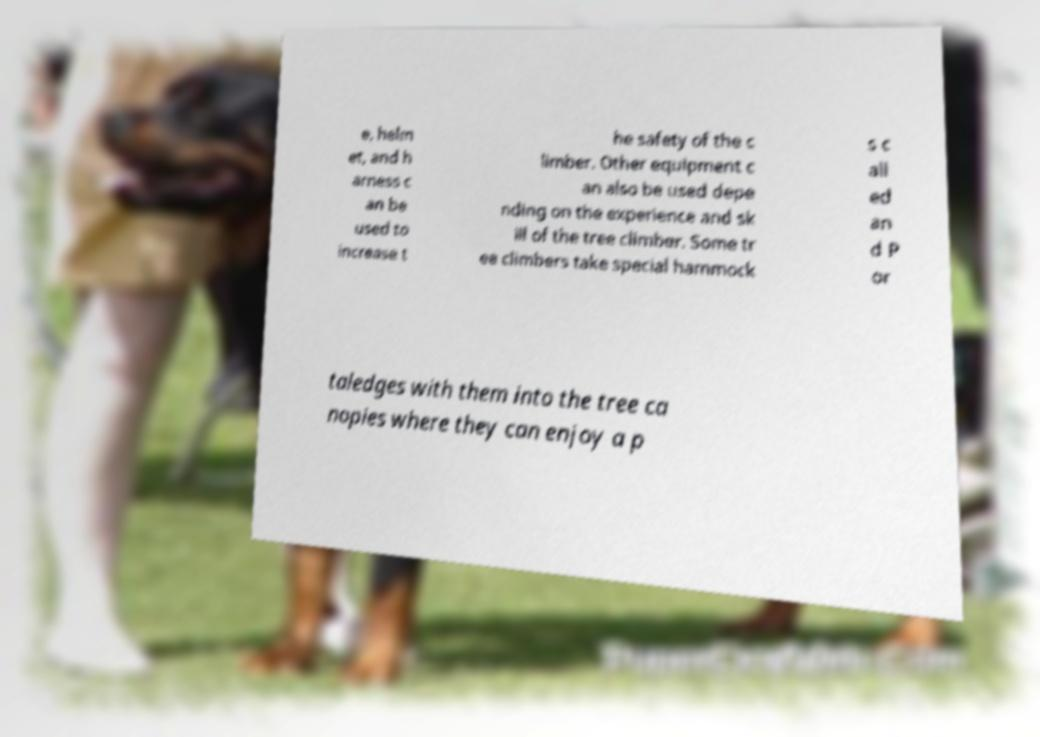Please identify and transcribe the text found in this image. e, helm et, and h arness c an be used to increase t he safety of the c limber. Other equipment c an also be used depe nding on the experience and sk ill of the tree climber. Some tr ee climbers take special hammock s c all ed an d P or taledges with them into the tree ca nopies where they can enjoy a p 